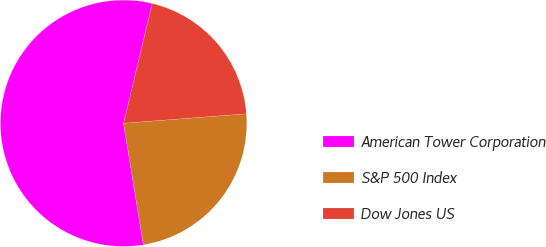Convert chart to OTSL. <chart><loc_0><loc_0><loc_500><loc_500><pie_chart><fcel>American Tower Corporation<fcel>S&P 500 Index<fcel>Dow Jones US<nl><fcel>56.31%<fcel>23.66%<fcel>20.03%<nl></chart> 